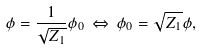<formula> <loc_0><loc_0><loc_500><loc_500>\phi = \frac { 1 } { \sqrt { Z _ { 1 } } } \phi _ { 0 } \, \Leftrightarrow \, \phi _ { 0 } = \sqrt { Z _ { 1 } } \phi ,</formula> 